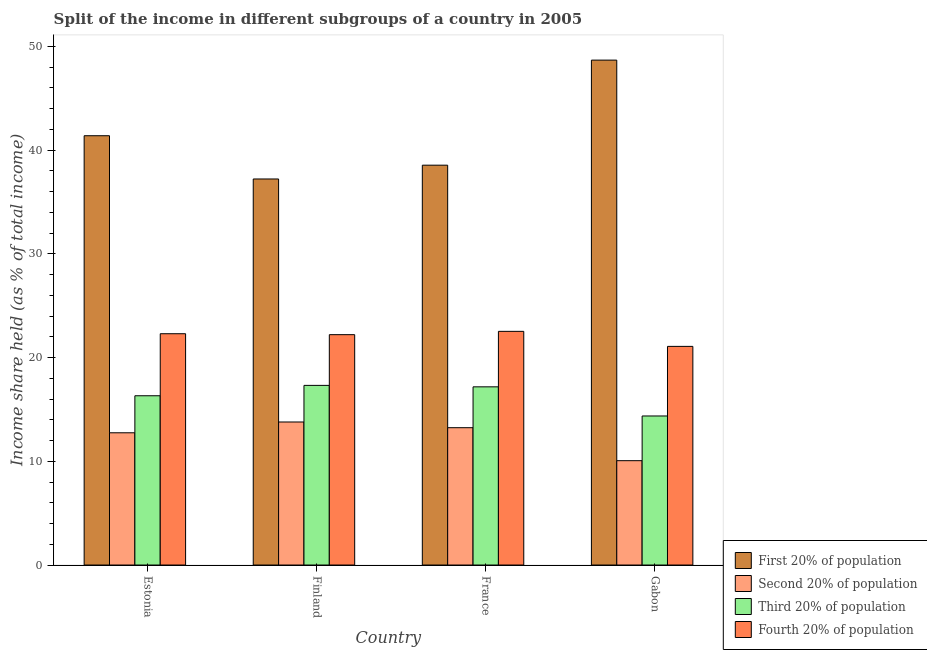How many bars are there on the 3rd tick from the left?
Provide a succinct answer. 4. How many bars are there on the 2nd tick from the right?
Ensure brevity in your answer.  4. What is the label of the 4th group of bars from the left?
Your answer should be very brief. Gabon. What is the share of the income held by second 20% of the population in Finland?
Ensure brevity in your answer.  13.79. Across all countries, what is the maximum share of the income held by third 20% of the population?
Give a very brief answer. 17.32. Across all countries, what is the minimum share of the income held by fourth 20% of the population?
Your answer should be very brief. 21.08. In which country was the share of the income held by third 20% of the population minimum?
Offer a terse response. Gabon. What is the total share of the income held by second 20% of the population in the graph?
Ensure brevity in your answer.  49.84. What is the difference between the share of the income held by fourth 20% of the population in Finland and that in Gabon?
Your answer should be compact. 1.13. What is the difference between the share of the income held by third 20% of the population in France and the share of the income held by fourth 20% of the population in Finland?
Offer a terse response. -5.03. What is the average share of the income held by fourth 20% of the population per country?
Give a very brief answer. 22.03. What is the difference between the share of the income held by third 20% of the population and share of the income held by fourth 20% of the population in Finland?
Your response must be concise. -4.89. In how many countries, is the share of the income held by first 20% of the population greater than 8 %?
Your response must be concise. 4. What is the ratio of the share of the income held by second 20% of the population in France to that in Gabon?
Your answer should be compact. 1.32. Is the share of the income held by first 20% of the population in Finland less than that in Gabon?
Ensure brevity in your answer.  Yes. Is the difference between the share of the income held by first 20% of the population in Estonia and France greater than the difference between the share of the income held by fourth 20% of the population in Estonia and France?
Offer a terse response. Yes. What is the difference between the highest and the second highest share of the income held by third 20% of the population?
Offer a very short reply. 0.14. What is the difference between the highest and the lowest share of the income held by second 20% of the population?
Ensure brevity in your answer.  3.73. Is the sum of the share of the income held by third 20% of the population in Finland and Gabon greater than the maximum share of the income held by second 20% of the population across all countries?
Your response must be concise. Yes. Is it the case that in every country, the sum of the share of the income held by fourth 20% of the population and share of the income held by first 20% of the population is greater than the sum of share of the income held by second 20% of the population and share of the income held by third 20% of the population?
Your answer should be compact. Yes. What does the 1st bar from the left in Finland represents?
Offer a terse response. First 20% of population. What does the 3rd bar from the right in Estonia represents?
Offer a very short reply. Second 20% of population. How many bars are there?
Your answer should be very brief. 16. What is the difference between two consecutive major ticks on the Y-axis?
Keep it short and to the point. 10. Are the values on the major ticks of Y-axis written in scientific E-notation?
Give a very brief answer. No. Does the graph contain any zero values?
Provide a short and direct response. No. Does the graph contain grids?
Keep it short and to the point. No. How many legend labels are there?
Ensure brevity in your answer.  4. How are the legend labels stacked?
Keep it short and to the point. Vertical. What is the title of the graph?
Offer a very short reply. Split of the income in different subgroups of a country in 2005. Does "Tertiary schools" appear as one of the legend labels in the graph?
Ensure brevity in your answer.  No. What is the label or title of the X-axis?
Your answer should be compact. Country. What is the label or title of the Y-axis?
Make the answer very short. Income share held (as % of total income). What is the Income share held (as % of total income) in First 20% of population in Estonia?
Keep it short and to the point. 41.39. What is the Income share held (as % of total income) of Second 20% of population in Estonia?
Your answer should be very brief. 12.75. What is the Income share held (as % of total income) in Third 20% of population in Estonia?
Give a very brief answer. 16.32. What is the Income share held (as % of total income) of Fourth 20% of population in Estonia?
Your response must be concise. 22.3. What is the Income share held (as % of total income) in First 20% of population in Finland?
Make the answer very short. 37.22. What is the Income share held (as % of total income) of Second 20% of population in Finland?
Your answer should be very brief. 13.79. What is the Income share held (as % of total income) in Third 20% of population in Finland?
Provide a short and direct response. 17.32. What is the Income share held (as % of total income) of Fourth 20% of population in Finland?
Offer a terse response. 22.21. What is the Income share held (as % of total income) of First 20% of population in France?
Make the answer very short. 38.55. What is the Income share held (as % of total income) in Second 20% of population in France?
Give a very brief answer. 13.24. What is the Income share held (as % of total income) of Third 20% of population in France?
Offer a very short reply. 17.18. What is the Income share held (as % of total income) in Fourth 20% of population in France?
Your response must be concise. 22.53. What is the Income share held (as % of total income) of First 20% of population in Gabon?
Your answer should be very brief. 48.68. What is the Income share held (as % of total income) in Second 20% of population in Gabon?
Provide a succinct answer. 10.06. What is the Income share held (as % of total income) of Third 20% of population in Gabon?
Offer a terse response. 14.37. What is the Income share held (as % of total income) of Fourth 20% of population in Gabon?
Ensure brevity in your answer.  21.08. Across all countries, what is the maximum Income share held (as % of total income) in First 20% of population?
Offer a very short reply. 48.68. Across all countries, what is the maximum Income share held (as % of total income) of Second 20% of population?
Provide a short and direct response. 13.79. Across all countries, what is the maximum Income share held (as % of total income) in Third 20% of population?
Offer a very short reply. 17.32. Across all countries, what is the maximum Income share held (as % of total income) of Fourth 20% of population?
Ensure brevity in your answer.  22.53. Across all countries, what is the minimum Income share held (as % of total income) in First 20% of population?
Provide a short and direct response. 37.22. Across all countries, what is the minimum Income share held (as % of total income) in Second 20% of population?
Offer a very short reply. 10.06. Across all countries, what is the minimum Income share held (as % of total income) of Third 20% of population?
Give a very brief answer. 14.37. Across all countries, what is the minimum Income share held (as % of total income) of Fourth 20% of population?
Provide a short and direct response. 21.08. What is the total Income share held (as % of total income) of First 20% of population in the graph?
Provide a short and direct response. 165.84. What is the total Income share held (as % of total income) of Second 20% of population in the graph?
Your response must be concise. 49.84. What is the total Income share held (as % of total income) of Third 20% of population in the graph?
Your response must be concise. 65.19. What is the total Income share held (as % of total income) in Fourth 20% of population in the graph?
Your response must be concise. 88.12. What is the difference between the Income share held (as % of total income) of First 20% of population in Estonia and that in Finland?
Ensure brevity in your answer.  4.17. What is the difference between the Income share held (as % of total income) of Second 20% of population in Estonia and that in Finland?
Make the answer very short. -1.04. What is the difference between the Income share held (as % of total income) of Third 20% of population in Estonia and that in Finland?
Give a very brief answer. -1. What is the difference between the Income share held (as % of total income) in Fourth 20% of population in Estonia and that in Finland?
Your answer should be compact. 0.09. What is the difference between the Income share held (as % of total income) in First 20% of population in Estonia and that in France?
Offer a very short reply. 2.84. What is the difference between the Income share held (as % of total income) of Second 20% of population in Estonia and that in France?
Provide a succinct answer. -0.49. What is the difference between the Income share held (as % of total income) in Third 20% of population in Estonia and that in France?
Give a very brief answer. -0.86. What is the difference between the Income share held (as % of total income) in Fourth 20% of population in Estonia and that in France?
Provide a succinct answer. -0.23. What is the difference between the Income share held (as % of total income) of First 20% of population in Estonia and that in Gabon?
Provide a short and direct response. -7.29. What is the difference between the Income share held (as % of total income) in Second 20% of population in Estonia and that in Gabon?
Your response must be concise. 2.69. What is the difference between the Income share held (as % of total income) of Third 20% of population in Estonia and that in Gabon?
Provide a short and direct response. 1.95. What is the difference between the Income share held (as % of total income) of Fourth 20% of population in Estonia and that in Gabon?
Your answer should be compact. 1.22. What is the difference between the Income share held (as % of total income) in First 20% of population in Finland and that in France?
Make the answer very short. -1.33. What is the difference between the Income share held (as % of total income) of Second 20% of population in Finland and that in France?
Keep it short and to the point. 0.55. What is the difference between the Income share held (as % of total income) in Third 20% of population in Finland and that in France?
Your answer should be compact. 0.14. What is the difference between the Income share held (as % of total income) of Fourth 20% of population in Finland and that in France?
Your response must be concise. -0.32. What is the difference between the Income share held (as % of total income) in First 20% of population in Finland and that in Gabon?
Give a very brief answer. -11.46. What is the difference between the Income share held (as % of total income) of Second 20% of population in Finland and that in Gabon?
Keep it short and to the point. 3.73. What is the difference between the Income share held (as % of total income) of Third 20% of population in Finland and that in Gabon?
Give a very brief answer. 2.95. What is the difference between the Income share held (as % of total income) of Fourth 20% of population in Finland and that in Gabon?
Offer a very short reply. 1.13. What is the difference between the Income share held (as % of total income) of First 20% of population in France and that in Gabon?
Provide a succinct answer. -10.13. What is the difference between the Income share held (as % of total income) in Second 20% of population in France and that in Gabon?
Give a very brief answer. 3.18. What is the difference between the Income share held (as % of total income) of Third 20% of population in France and that in Gabon?
Your answer should be very brief. 2.81. What is the difference between the Income share held (as % of total income) of Fourth 20% of population in France and that in Gabon?
Make the answer very short. 1.45. What is the difference between the Income share held (as % of total income) of First 20% of population in Estonia and the Income share held (as % of total income) of Second 20% of population in Finland?
Offer a terse response. 27.6. What is the difference between the Income share held (as % of total income) in First 20% of population in Estonia and the Income share held (as % of total income) in Third 20% of population in Finland?
Offer a very short reply. 24.07. What is the difference between the Income share held (as % of total income) in First 20% of population in Estonia and the Income share held (as % of total income) in Fourth 20% of population in Finland?
Your answer should be very brief. 19.18. What is the difference between the Income share held (as % of total income) in Second 20% of population in Estonia and the Income share held (as % of total income) in Third 20% of population in Finland?
Provide a short and direct response. -4.57. What is the difference between the Income share held (as % of total income) in Second 20% of population in Estonia and the Income share held (as % of total income) in Fourth 20% of population in Finland?
Your answer should be very brief. -9.46. What is the difference between the Income share held (as % of total income) of Third 20% of population in Estonia and the Income share held (as % of total income) of Fourth 20% of population in Finland?
Provide a succinct answer. -5.89. What is the difference between the Income share held (as % of total income) of First 20% of population in Estonia and the Income share held (as % of total income) of Second 20% of population in France?
Give a very brief answer. 28.15. What is the difference between the Income share held (as % of total income) in First 20% of population in Estonia and the Income share held (as % of total income) in Third 20% of population in France?
Your response must be concise. 24.21. What is the difference between the Income share held (as % of total income) of First 20% of population in Estonia and the Income share held (as % of total income) of Fourth 20% of population in France?
Ensure brevity in your answer.  18.86. What is the difference between the Income share held (as % of total income) of Second 20% of population in Estonia and the Income share held (as % of total income) of Third 20% of population in France?
Offer a terse response. -4.43. What is the difference between the Income share held (as % of total income) of Second 20% of population in Estonia and the Income share held (as % of total income) of Fourth 20% of population in France?
Provide a short and direct response. -9.78. What is the difference between the Income share held (as % of total income) in Third 20% of population in Estonia and the Income share held (as % of total income) in Fourth 20% of population in France?
Give a very brief answer. -6.21. What is the difference between the Income share held (as % of total income) in First 20% of population in Estonia and the Income share held (as % of total income) in Second 20% of population in Gabon?
Provide a short and direct response. 31.33. What is the difference between the Income share held (as % of total income) of First 20% of population in Estonia and the Income share held (as % of total income) of Third 20% of population in Gabon?
Your answer should be compact. 27.02. What is the difference between the Income share held (as % of total income) in First 20% of population in Estonia and the Income share held (as % of total income) in Fourth 20% of population in Gabon?
Give a very brief answer. 20.31. What is the difference between the Income share held (as % of total income) of Second 20% of population in Estonia and the Income share held (as % of total income) of Third 20% of population in Gabon?
Your response must be concise. -1.62. What is the difference between the Income share held (as % of total income) of Second 20% of population in Estonia and the Income share held (as % of total income) of Fourth 20% of population in Gabon?
Offer a terse response. -8.33. What is the difference between the Income share held (as % of total income) in Third 20% of population in Estonia and the Income share held (as % of total income) in Fourth 20% of population in Gabon?
Keep it short and to the point. -4.76. What is the difference between the Income share held (as % of total income) in First 20% of population in Finland and the Income share held (as % of total income) in Second 20% of population in France?
Your answer should be very brief. 23.98. What is the difference between the Income share held (as % of total income) in First 20% of population in Finland and the Income share held (as % of total income) in Third 20% of population in France?
Your answer should be very brief. 20.04. What is the difference between the Income share held (as % of total income) of First 20% of population in Finland and the Income share held (as % of total income) of Fourth 20% of population in France?
Your answer should be very brief. 14.69. What is the difference between the Income share held (as % of total income) in Second 20% of population in Finland and the Income share held (as % of total income) in Third 20% of population in France?
Your answer should be very brief. -3.39. What is the difference between the Income share held (as % of total income) of Second 20% of population in Finland and the Income share held (as % of total income) of Fourth 20% of population in France?
Make the answer very short. -8.74. What is the difference between the Income share held (as % of total income) in Third 20% of population in Finland and the Income share held (as % of total income) in Fourth 20% of population in France?
Your answer should be compact. -5.21. What is the difference between the Income share held (as % of total income) of First 20% of population in Finland and the Income share held (as % of total income) of Second 20% of population in Gabon?
Keep it short and to the point. 27.16. What is the difference between the Income share held (as % of total income) in First 20% of population in Finland and the Income share held (as % of total income) in Third 20% of population in Gabon?
Your response must be concise. 22.85. What is the difference between the Income share held (as % of total income) in First 20% of population in Finland and the Income share held (as % of total income) in Fourth 20% of population in Gabon?
Your answer should be very brief. 16.14. What is the difference between the Income share held (as % of total income) of Second 20% of population in Finland and the Income share held (as % of total income) of Third 20% of population in Gabon?
Make the answer very short. -0.58. What is the difference between the Income share held (as % of total income) of Second 20% of population in Finland and the Income share held (as % of total income) of Fourth 20% of population in Gabon?
Make the answer very short. -7.29. What is the difference between the Income share held (as % of total income) of Third 20% of population in Finland and the Income share held (as % of total income) of Fourth 20% of population in Gabon?
Ensure brevity in your answer.  -3.76. What is the difference between the Income share held (as % of total income) in First 20% of population in France and the Income share held (as % of total income) in Second 20% of population in Gabon?
Ensure brevity in your answer.  28.49. What is the difference between the Income share held (as % of total income) in First 20% of population in France and the Income share held (as % of total income) in Third 20% of population in Gabon?
Provide a short and direct response. 24.18. What is the difference between the Income share held (as % of total income) of First 20% of population in France and the Income share held (as % of total income) of Fourth 20% of population in Gabon?
Offer a terse response. 17.47. What is the difference between the Income share held (as % of total income) in Second 20% of population in France and the Income share held (as % of total income) in Third 20% of population in Gabon?
Your answer should be compact. -1.13. What is the difference between the Income share held (as % of total income) of Second 20% of population in France and the Income share held (as % of total income) of Fourth 20% of population in Gabon?
Your response must be concise. -7.84. What is the difference between the Income share held (as % of total income) in Third 20% of population in France and the Income share held (as % of total income) in Fourth 20% of population in Gabon?
Give a very brief answer. -3.9. What is the average Income share held (as % of total income) of First 20% of population per country?
Ensure brevity in your answer.  41.46. What is the average Income share held (as % of total income) in Second 20% of population per country?
Your response must be concise. 12.46. What is the average Income share held (as % of total income) in Third 20% of population per country?
Give a very brief answer. 16.3. What is the average Income share held (as % of total income) in Fourth 20% of population per country?
Your response must be concise. 22.03. What is the difference between the Income share held (as % of total income) of First 20% of population and Income share held (as % of total income) of Second 20% of population in Estonia?
Offer a terse response. 28.64. What is the difference between the Income share held (as % of total income) of First 20% of population and Income share held (as % of total income) of Third 20% of population in Estonia?
Make the answer very short. 25.07. What is the difference between the Income share held (as % of total income) in First 20% of population and Income share held (as % of total income) in Fourth 20% of population in Estonia?
Your answer should be compact. 19.09. What is the difference between the Income share held (as % of total income) of Second 20% of population and Income share held (as % of total income) of Third 20% of population in Estonia?
Offer a terse response. -3.57. What is the difference between the Income share held (as % of total income) in Second 20% of population and Income share held (as % of total income) in Fourth 20% of population in Estonia?
Your answer should be very brief. -9.55. What is the difference between the Income share held (as % of total income) in Third 20% of population and Income share held (as % of total income) in Fourth 20% of population in Estonia?
Keep it short and to the point. -5.98. What is the difference between the Income share held (as % of total income) in First 20% of population and Income share held (as % of total income) in Second 20% of population in Finland?
Offer a very short reply. 23.43. What is the difference between the Income share held (as % of total income) in First 20% of population and Income share held (as % of total income) in Third 20% of population in Finland?
Your response must be concise. 19.9. What is the difference between the Income share held (as % of total income) in First 20% of population and Income share held (as % of total income) in Fourth 20% of population in Finland?
Keep it short and to the point. 15.01. What is the difference between the Income share held (as % of total income) in Second 20% of population and Income share held (as % of total income) in Third 20% of population in Finland?
Your answer should be compact. -3.53. What is the difference between the Income share held (as % of total income) in Second 20% of population and Income share held (as % of total income) in Fourth 20% of population in Finland?
Your answer should be very brief. -8.42. What is the difference between the Income share held (as % of total income) in Third 20% of population and Income share held (as % of total income) in Fourth 20% of population in Finland?
Ensure brevity in your answer.  -4.89. What is the difference between the Income share held (as % of total income) of First 20% of population and Income share held (as % of total income) of Second 20% of population in France?
Provide a succinct answer. 25.31. What is the difference between the Income share held (as % of total income) in First 20% of population and Income share held (as % of total income) in Third 20% of population in France?
Give a very brief answer. 21.37. What is the difference between the Income share held (as % of total income) in First 20% of population and Income share held (as % of total income) in Fourth 20% of population in France?
Make the answer very short. 16.02. What is the difference between the Income share held (as % of total income) in Second 20% of population and Income share held (as % of total income) in Third 20% of population in France?
Your response must be concise. -3.94. What is the difference between the Income share held (as % of total income) of Second 20% of population and Income share held (as % of total income) of Fourth 20% of population in France?
Ensure brevity in your answer.  -9.29. What is the difference between the Income share held (as % of total income) in Third 20% of population and Income share held (as % of total income) in Fourth 20% of population in France?
Offer a very short reply. -5.35. What is the difference between the Income share held (as % of total income) of First 20% of population and Income share held (as % of total income) of Second 20% of population in Gabon?
Offer a very short reply. 38.62. What is the difference between the Income share held (as % of total income) in First 20% of population and Income share held (as % of total income) in Third 20% of population in Gabon?
Keep it short and to the point. 34.31. What is the difference between the Income share held (as % of total income) of First 20% of population and Income share held (as % of total income) of Fourth 20% of population in Gabon?
Offer a very short reply. 27.6. What is the difference between the Income share held (as % of total income) in Second 20% of population and Income share held (as % of total income) in Third 20% of population in Gabon?
Make the answer very short. -4.31. What is the difference between the Income share held (as % of total income) of Second 20% of population and Income share held (as % of total income) of Fourth 20% of population in Gabon?
Your answer should be very brief. -11.02. What is the difference between the Income share held (as % of total income) of Third 20% of population and Income share held (as % of total income) of Fourth 20% of population in Gabon?
Offer a terse response. -6.71. What is the ratio of the Income share held (as % of total income) of First 20% of population in Estonia to that in Finland?
Your answer should be very brief. 1.11. What is the ratio of the Income share held (as % of total income) in Second 20% of population in Estonia to that in Finland?
Offer a very short reply. 0.92. What is the ratio of the Income share held (as % of total income) in Third 20% of population in Estonia to that in Finland?
Your response must be concise. 0.94. What is the ratio of the Income share held (as % of total income) in First 20% of population in Estonia to that in France?
Offer a terse response. 1.07. What is the ratio of the Income share held (as % of total income) in Third 20% of population in Estonia to that in France?
Offer a very short reply. 0.95. What is the ratio of the Income share held (as % of total income) in Fourth 20% of population in Estonia to that in France?
Offer a terse response. 0.99. What is the ratio of the Income share held (as % of total income) of First 20% of population in Estonia to that in Gabon?
Your answer should be very brief. 0.85. What is the ratio of the Income share held (as % of total income) of Second 20% of population in Estonia to that in Gabon?
Keep it short and to the point. 1.27. What is the ratio of the Income share held (as % of total income) in Third 20% of population in Estonia to that in Gabon?
Provide a short and direct response. 1.14. What is the ratio of the Income share held (as % of total income) in Fourth 20% of population in Estonia to that in Gabon?
Ensure brevity in your answer.  1.06. What is the ratio of the Income share held (as % of total income) of First 20% of population in Finland to that in France?
Offer a very short reply. 0.97. What is the ratio of the Income share held (as % of total income) of Second 20% of population in Finland to that in France?
Offer a terse response. 1.04. What is the ratio of the Income share held (as % of total income) in Third 20% of population in Finland to that in France?
Provide a short and direct response. 1.01. What is the ratio of the Income share held (as % of total income) in Fourth 20% of population in Finland to that in France?
Offer a terse response. 0.99. What is the ratio of the Income share held (as % of total income) in First 20% of population in Finland to that in Gabon?
Your answer should be compact. 0.76. What is the ratio of the Income share held (as % of total income) of Second 20% of population in Finland to that in Gabon?
Your answer should be very brief. 1.37. What is the ratio of the Income share held (as % of total income) in Third 20% of population in Finland to that in Gabon?
Offer a terse response. 1.21. What is the ratio of the Income share held (as % of total income) in Fourth 20% of population in Finland to that in Gabon?
Provide a succinct answer. 1.05. What is the ratio of the Income share held (as % of total income) in First 20% of population in France to that in Gabon?
Provide a short and direct response. 0.79. What is the ratio of the Income share held (as % of total income) of Second 20% of population in France to that in Gabon?
Your answer should be very brief. 1.32. What is the ratio of the Income share held (as % of total income) of Third 20% of population in France to that in Gabon?
Keep it short and to the point. 1.2. What is the ratio of the Income share held (as % of total income) of Fourth 20% of population in France to that in Gabon?
Ensure brevity in your answer.  1.07. What is the difference between the highest and the second highest Income share held (as % of total income) in First 20% of population?
Your answer should be compact. 7.29. What is the difference between the highest and the second highest Income share held (as % of total income) of Second 20% of population?
Keep it short and to the point. 0.55. What is the difference between the highest and the second highest Income share held (as % of total income) in Third 20% of population?
Keep it short and to the point. 0.14. What is the difference between the highest and the second highest Income share held (as % of total income) in Fourth 20% of population?
Make the answer very short. 0.23. What is the difference between the highest and the lowest Income share held (as % of total income) of First 20% of population?
Ensure brevity in your answer.  11.46. What is the difference between the highest and the lowest Income share held (as % of total income) of Second 20% of population?
Offer a terse response. 3.73. What is the difference between the highest and the lowest Income share held (as % of total income) of Third 20% of population?
Make the answer very short. 2.95. What is the difference between the highest and the lowest Income share held (as % of total income) in Fourth 20% of population?
Provide a short and direct response. 1.45. 